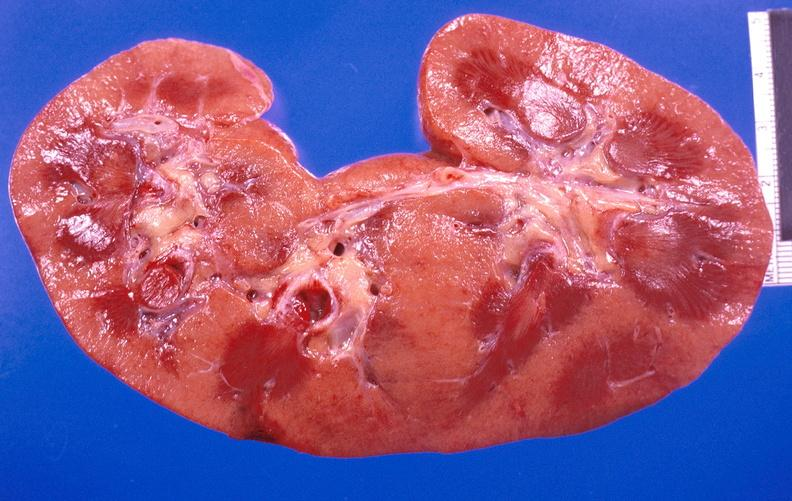where is this?
Answer the question using a single word or phrase. Urinary 